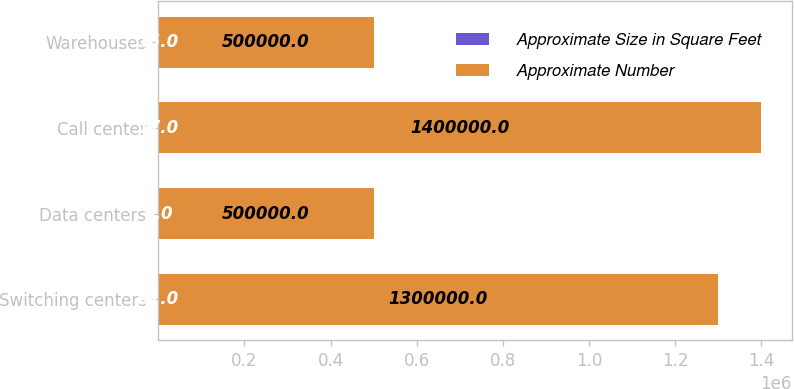Convert chart. <chart><loc_0><loc_0><loc_500><loc_500><stacked_bar_chart><ecel><fcel>Switching centers<fcel>Data centers<fcel>Call center<fcel>Warehouses<nl><fcel>Approximate Size in Square Feet<fcel>61<fcel>6<fcel>17<fcel>15<nl><fcel>Approximate Number<fcel>1.3e+06<fcel>500000<fcel>1.4e+06<fcel>500000<nl></chart> 